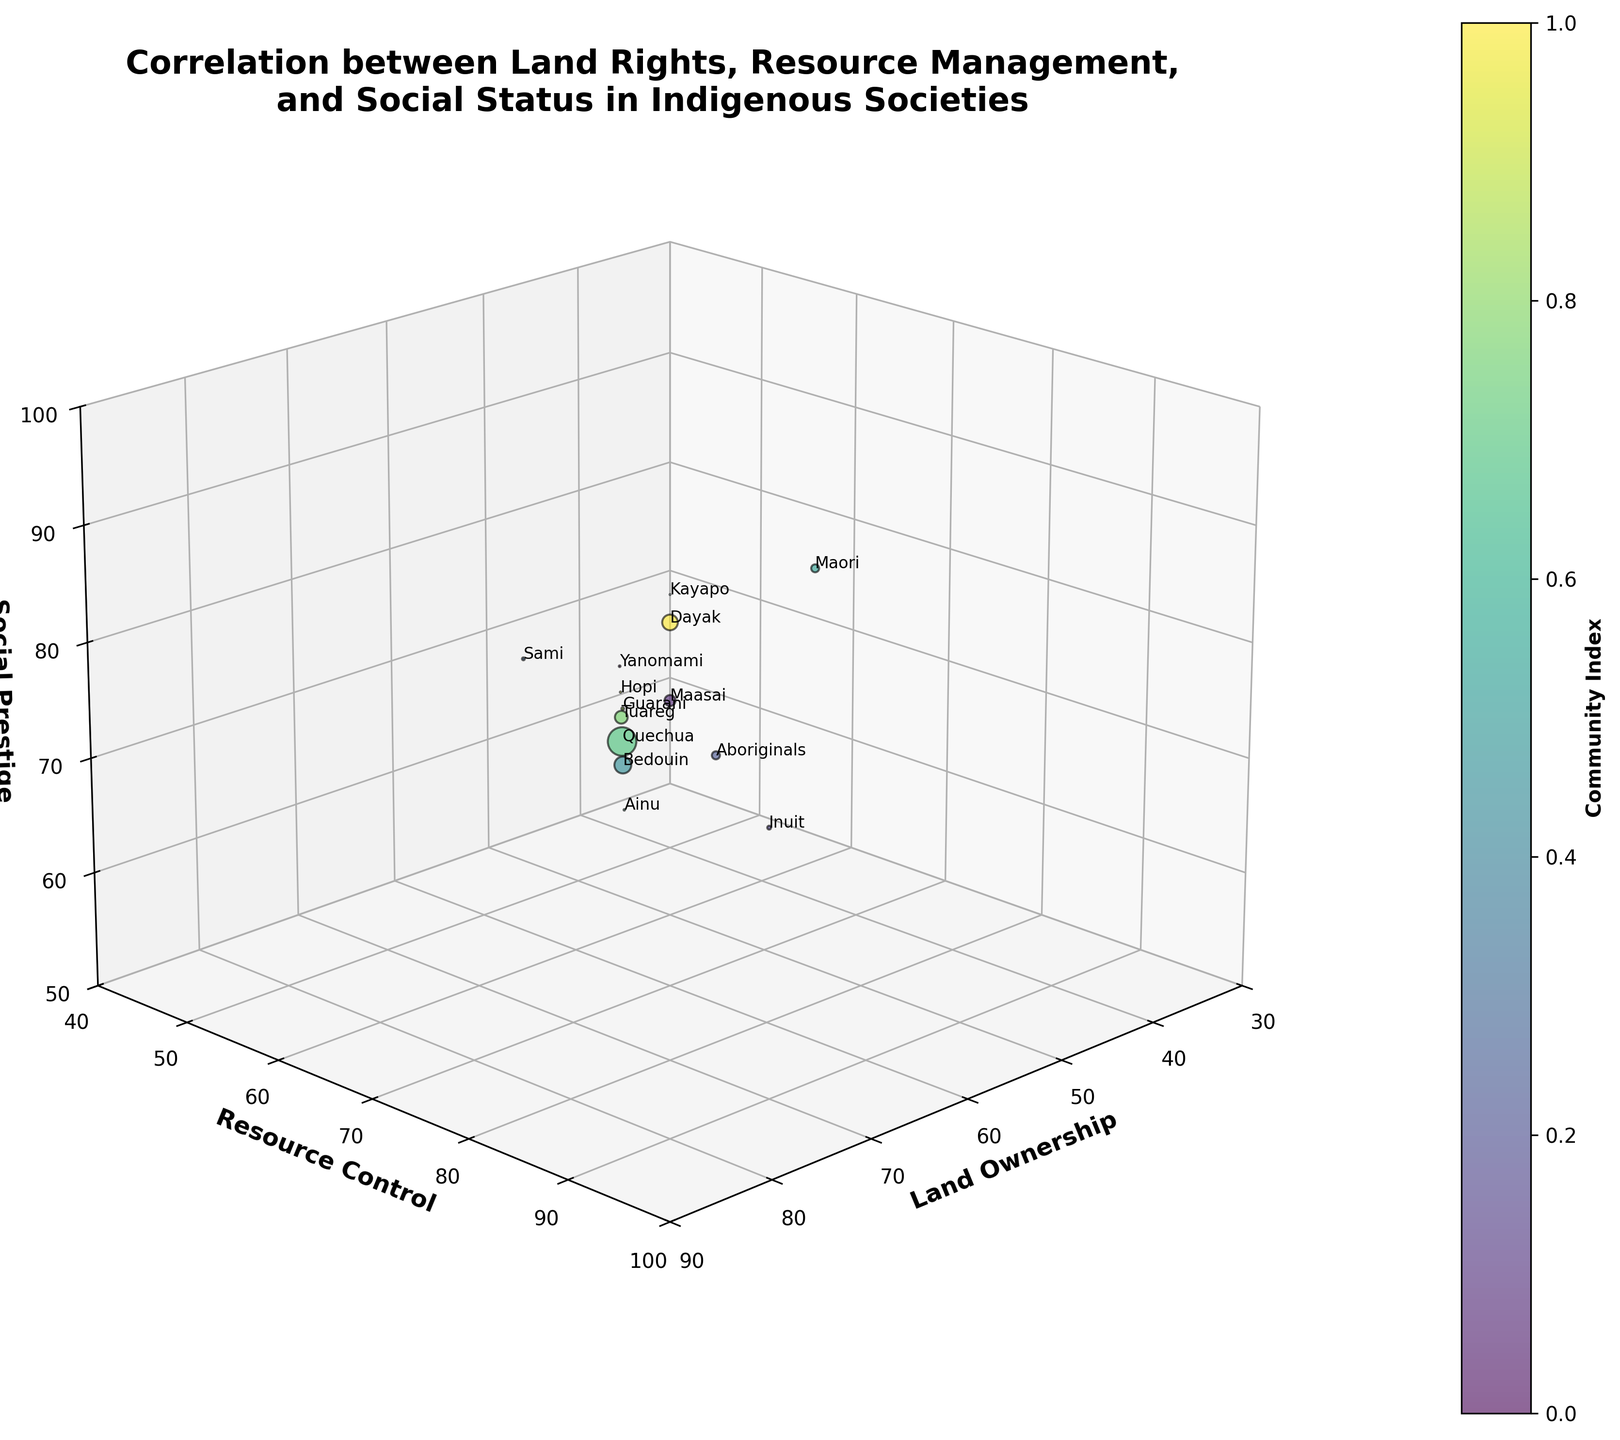What community has the highest social prestige? Observing the z-axis titled "Social Prestige," the Kayapo community possesses the highest value at 95.
Answer: Kayapo How many communities have a resource control above 80? The y-axis titled "Resource Control" shows Yanomami (80), Inuit (85), Kayapo (90), Maori (75), and Dayak (85). Counting these communities, there are five.
Answer: 5 Which community has the lowest land ownership? The x-axis titled "Land Ownership" shows that the Aboriginals have the lowest value at 40.
Answer: Aboriginals What is the average social prestige of communities with land ownership above 65? Communities with land ownership above 65 are Yanomami (85), Inuit (70), Kayapo (95), Sami (80), Hopi (80), and Dayak (90). Their average social prestige is calculated as (85 + 70 + 95 + 80 + 80 + 90) / 6 = 83.33
Answer: 83.33 Is there a strong correlation between land ownership and resource control? By visually examining the spread of points along the x and y axes, the points do not tightly cluster around a line, indicating only a moderate correlation.
Answer: Moderate Which community has the largest population? Population sizes are represented by the bubble sizes. The Quechua community has the largest bubble, indicating the largest population.
Answer: Quechua Among the Sami and Maori communities, which has higher resource control? Observing the y-axis values, Maori has a resource control of 75, which is higher than Sami's 65.
Answer: Maori How does the population of the Inuit compare to that of the Ainu? Population is represented by bubble sizes. Comparatively, the Inuit has a larger bubble indicating a larger population than the Ainu.
Answer: Inuit is larger What is the combined social prestige of the Yanomami, Maasai, and Kayapo? The social prestige values of these communities are Yanomami (85), Maasai (75), and Kayapo (95). Summing these values gives 85 + 75 + 95 = 255.
Answer: 255 How does land ownership differ between Tuareg and Dayak communities? Comparing the x-axis values, Tuareg has a land ownership of 65, while Dayak has 75, resulting in a difference of 75 - 65 = 10.
Answer: 10 